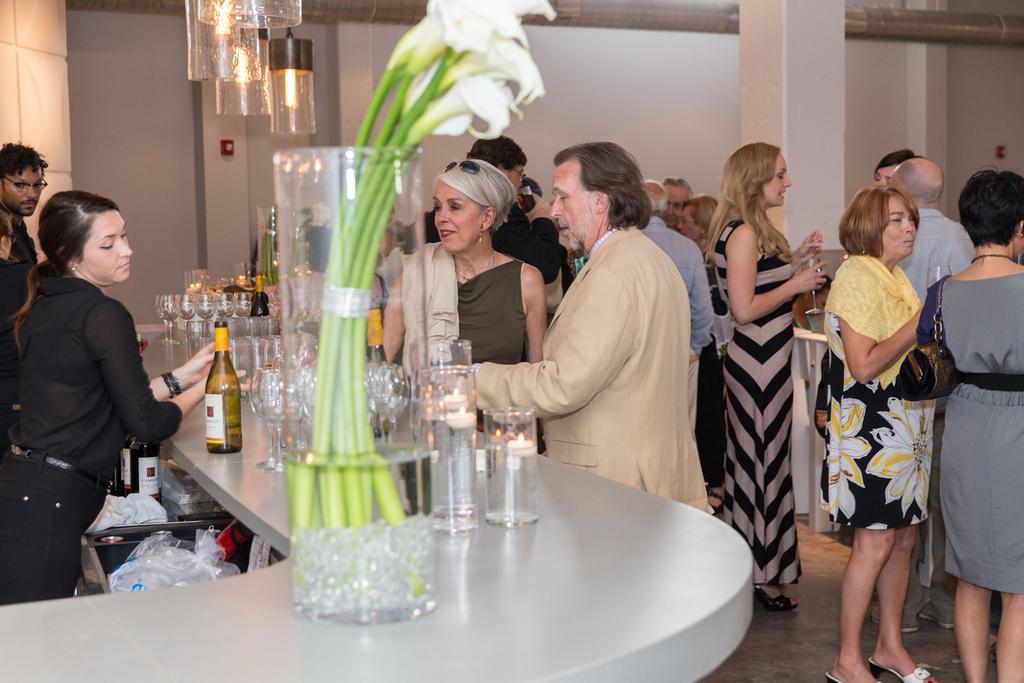Please provide a concise description of this image. In this image I can see a group of people standing on the right hand side and some of them are holding wine glasses in their hands. On the left hand side of the image I can see three people standing are separated by a cabin from the other people, on the cabins platform I can see some wine glasses, bottles, flower vase, candles. At the top of the image I can see some lights hanging. There are two people standing just outside the cabin interacting with people inside. 